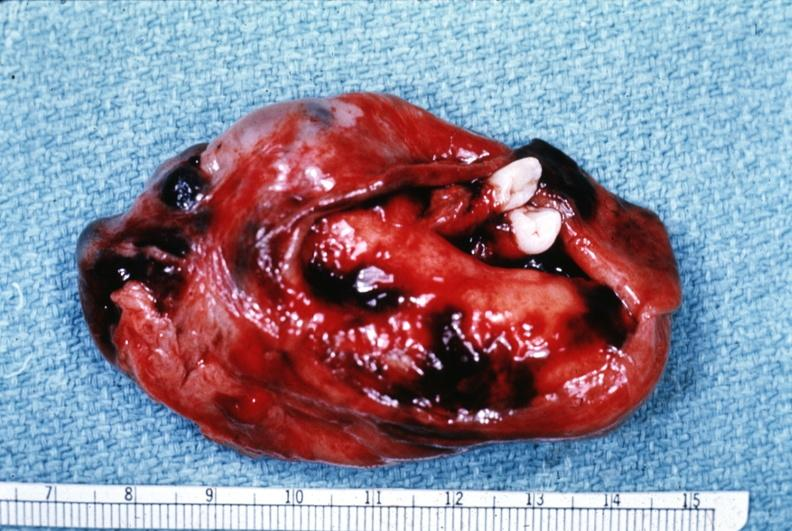s siamese twins present?
Answer the question using a single word or phrase. No 